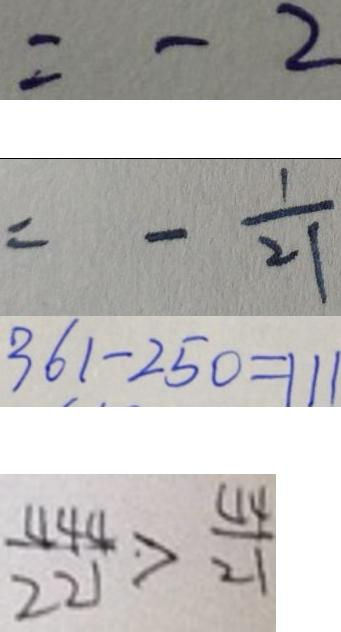Convert formula to latex. <formula><loc_0><loc_0><loc_500><loc_500>= - 2 
 = - \frac { 1 } { 2 1 } 
 3 6 1 - 2 5 0 = 1 1 1 
 \frac { 4 4 4 } { 2 2 1 } > \frac { 4 4 } { 2 1 }</formula> 